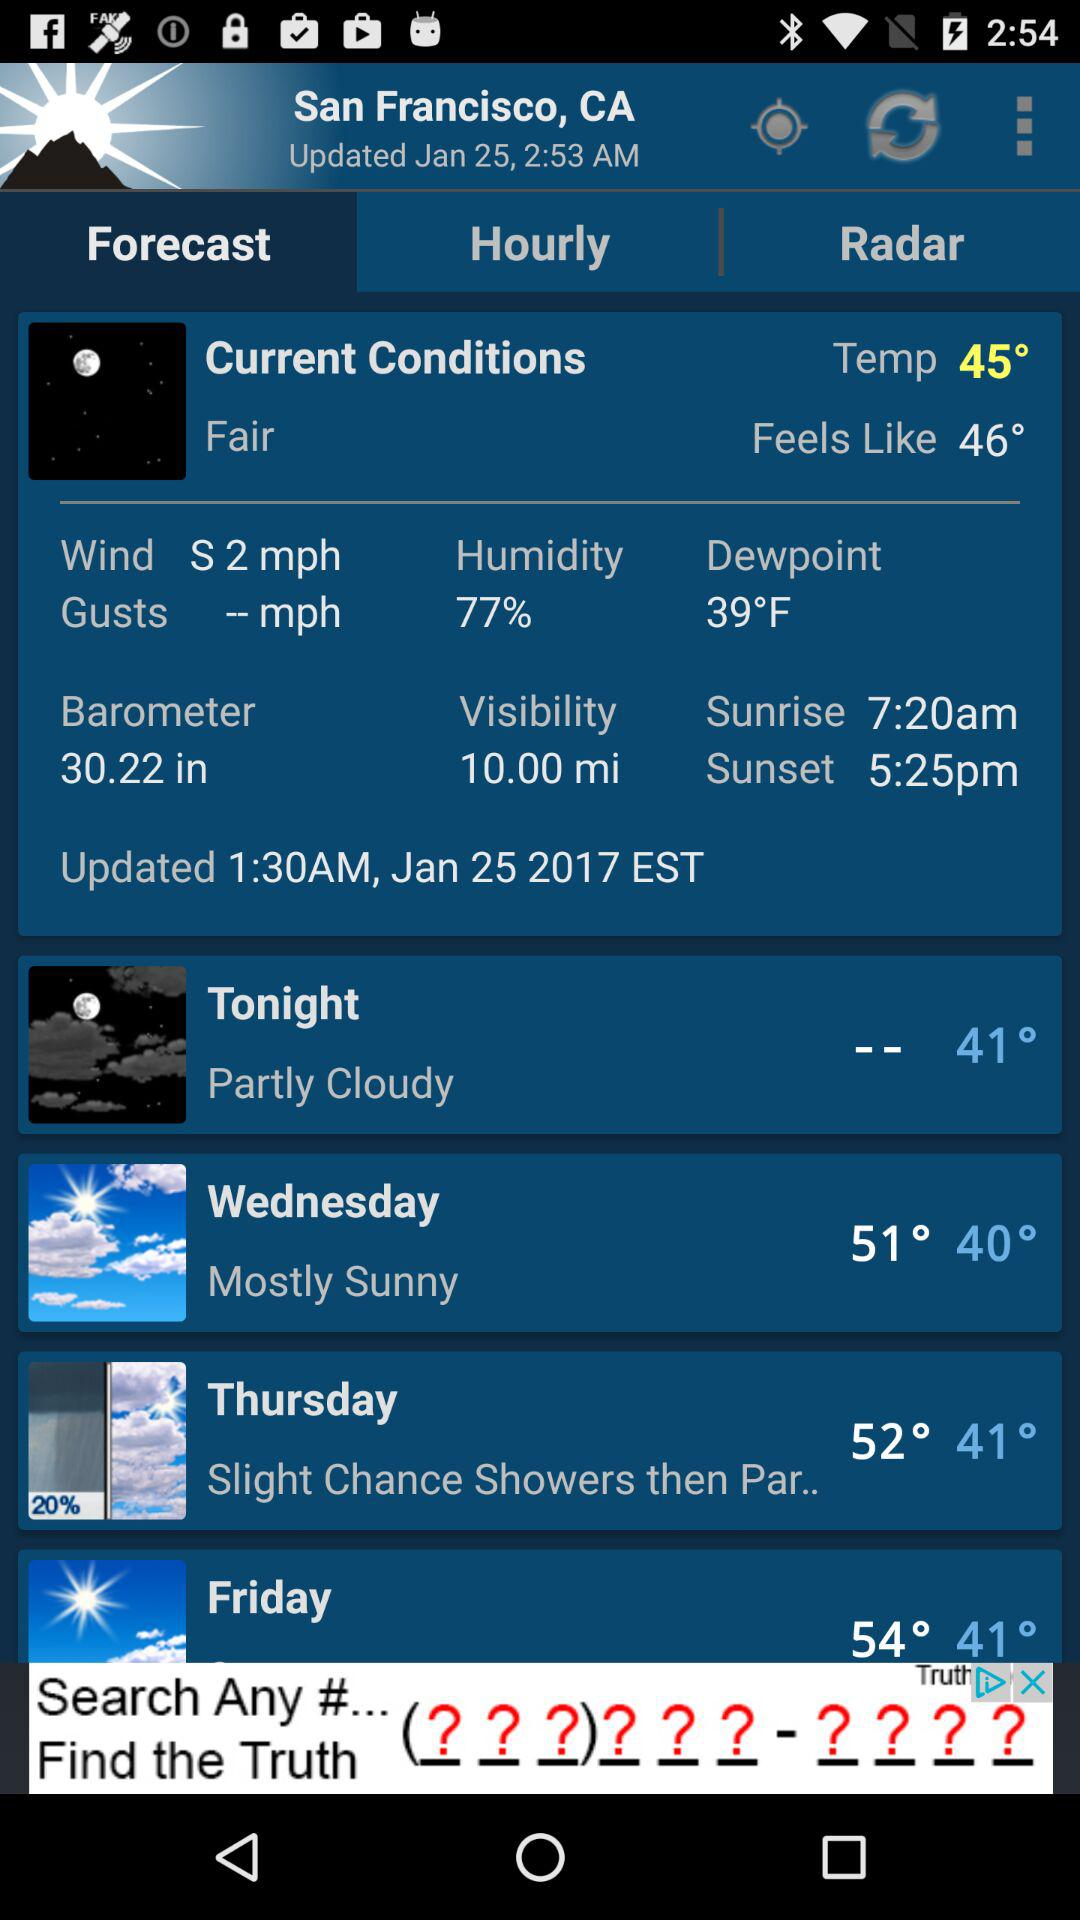What is the temperature in San Francisco? The temperature in San Francisco is 45°. 